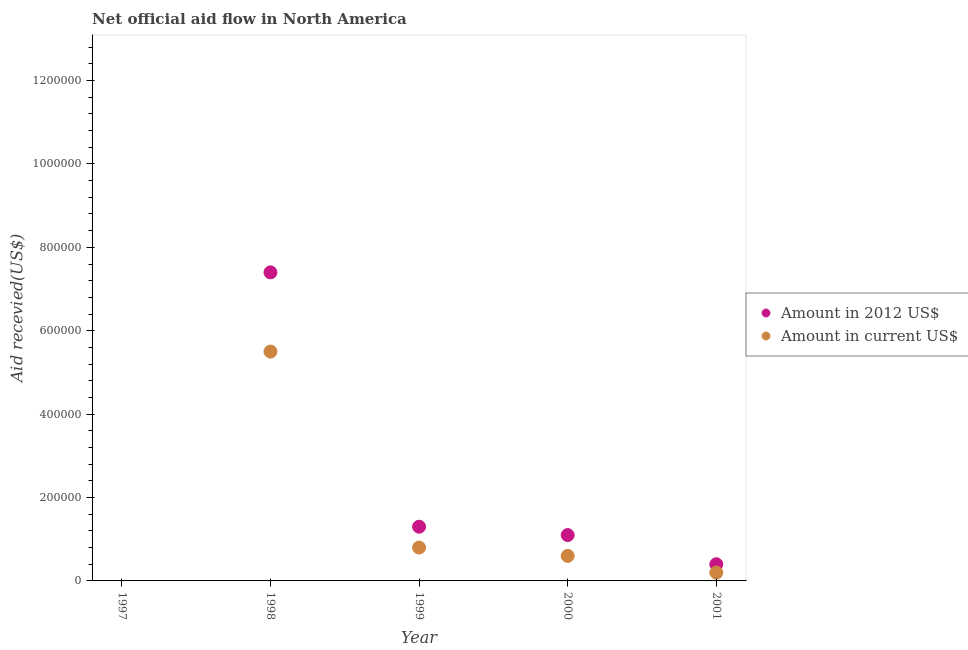How many different coloured dotlines are there?
Make the answer very short. 2. Is the number of dotlines equal to the number of legend labels?
Ensure brevity in your answer.  No. What is the amount of aid received(expressed in us$) in 1997?
Keep it short and to the point. 0. Across all years, what is the maximum amount of aid received(expressed in us$)?
Ensure brevity in your answer.  5.50e+05. In which year was the amount of aid received(expressed in 2012 us$) maximum?
Your response must be concise. 1998. What is the total amount of aid received(expressed in 2012 us$) in the graph?
Your response must be concise. 1.02e+06. What is the difference between the amount of aid received(expressed in us$) in 1998 and that in 2001?
Your answer should be very brief. 5.30e+05. What is the difference between the amount of aid received(expressed in 2012 us$) in 2001 and the amount of aid received(expressed in us$) in 2000?
Offer a very short reply. -2.00e+04. What is the average amount of aid received(expressed in us$) per year?
Make the answer very short. 1.42e+05. In the year 2001, what is the difference between the amount of aid received(expressed in us$) and amount of aid received(expressed in 2012 us$)?
Provide a short and direct response. -2.00e+04. In how many years, is the amount of aid received(expressed in 2012 us$) greater than 480000 US$?
Provide a short and direct response. 1. What is the ratio of the amount of aid received(expressed in us$) in 1998 to that in 1999?
Offer a terse response. 6.88. Is the amount of aid received(expressed in us$) in 2000 less than that in 2001?
Provide a succinct answer. No. Is the difference between the amount of aid received(expressed in us$) in 1999 and 2001 greater than the difference between the amount of aid received(expressed in 2012 us$) in 1999 and 2001?
Offer a very short reply. No. What is the difference between the highest and the second highest amount of aid received(expressed in us$)?
Make the answer very short. 4.70e+05. What is the difference between the highest and the lowest amount of aid received(expressed in 2012 us$)?
Your answer should be compact. 7.40e+05. Does the amount of aid received(expressed in 2012 us$) monotonically increase over the years?
Offer a terse response. No. Is the amount of aid received(expressed in us$) strictly greater than the amount of aid received(expressed in 2012 us$) over the years?
Your answer should be compact. No. How many years are there in the graph?
Offer a terse response. 5. Are the values on the major ticks of Y-axis written in scientific E-notation?
Provide a succinct answer. No. Does the graph contain any zero values?
Your answer should be compact. Yes. Does the graph contain grids?
Your answer should be compact. No. Where does the legend appear in the graph?
Ensure brevity in your answer.  Center right. How many legend labels are there?
Keep it short and to the point. 2. How are the legend labels stacked?
Ensure brevity in your answer.  Vertical. What is the title of the graph?
Your answer should be compact. Net official aid flow in North America. What is the label or title of the Y-axis?
Your answer should be very brief. Aid recevied(US$). What is the Aid recevied(US$) in Amount in 2012 US$ in 1997?
Provide a short and direct response. 0. What is the Aid recevied(US$) in Amount in current US$ in 1997?
Your answer should be very brief. 0. What is the Aid recevied(US$) of Amount in 2012 US$ in 1998?
Your answer should be compact. 7.40e+05. What is the Aid recevied(US$) in Amount in 2012 US$ in 1999?
Provide a short and direct response. 1.30e+05. What is the Aid recevied(US$) of Amount in current US$ in 1999?
Your answer should be compact. 8.00e+04. What is the Aid recevied(US$) of Amount in current US$ in 2000?
Provide a short and direct response. 6.00e+04. What is the Aid recevied(US$) of Amount in 2012 US$ in 2001?
Your answer should be compact. 4.00e+04. Across all years, what is the maximum Aid recevied(US$) of Amount in 2012 US$?
Give a very brief answer. 7.40e+05. Across all years, what is the maximum Aid recevied(US$) in Amount in current US$?
Make the answer very short. 5.50e+05. Across all years, what is the minimum Aid recevied(US$) of Amount in current US$?
Make the answer very short. 0. What is the total Aid recevied(US$) in Amount in 2012 US$ in the graph?
Provide a succinct answer. 1.02e+06. What is the total Aid recevied(US$) of Amount in current US$ in the graph?
Your response must be concise. 7.10e+05. What is the difference between the Aid recevied(US$) of Amount in 2012 US$ in 1998 and that in 1999?
Your answer should be compact. 6.10e+05. What is the difference between the Aid recevied(US$) in Amount in current US$ in 1998 and that in 1999?
Your answer should be very brief. 4.70e+05. What is the difference between the Aid recevied(US$) in Amount in 2012 US$ in 1998 and that in 2000?
Keep it short and to the point. 6.30e+05. What is the difference between the Aid recevied(US$) in Amount in current US$ in 1998 and that in 2001?
Give a very brief answer. 5.30e+05. What is the difference between the Aid recevied(US$) in Amount in 2012 US$ in 1999 and that in 2000?
Offer a very short reply. 2.00e+04. What is the difference between the Aid recevied(US$) in Amount in current US$ in 1999 and that in 2000?
Offer a very short reply. 2.00e+04. What is the difference between the Aid recevied(US$) in Amount in 2012 US$ in 1999 and that in 2001?
Offer a terse response. 9.00e+04. What is the difference between the Aid recevied(US$) of Amount in current US$ in 2000 and that in 2001?
Provide a short and direct response. 4.00e+04. What is the difference between the Aid recevied(US$) in Amount in 2012 US$ in 1998 and the Aid recevied(US$) in Amount in current US$ in 2000?
Your answer should be compact. 6.80e+05. What is the difference between the Aid recevied(US$) in Amount in 2012 US$ in 1998 and the Aid recevied(US$) in Amount in current US$ in 2001?
Ensure brevity in your answer.  7.20e+05. What is the difference between the Aid recevied(US$) of Amount in 2012 US$ in 1999 and the Aid recevied(US$) of Amount in current US$ in 2000?
Your answer should be very brief. 7.00e+04. What is the difference between the Aid recevied(US$) in Amount in 2012 US$ in 1999 and the Aid recevied(US$) in Amount in current US$ in 2001?
Make the answer very short. 1.10e+05. What is the average Aid recevied(US$) of Amount in 2012 US$ per year?
Offer a terse response. 2.04e+05. What is the average Aid recevied(US$) in Amount in current US$ per year?
Make the answer very short. 1.42e+05. In the year 1998, what is the difference between the Aid recevied(US$) in Amount in 2012 US$ and Aid recevied(US$) in Amount in current US$?
Offer a terse response. 1.90e+05. In the year 1999, what is the difference between the Aid recevied(US$) in Amount in 2012 US$ and Aid recevied(US$) in Amount in current US$?
Keep it short and to the point. 5.00e+04. In the year 2001, what is the difference between the Aid recevied(US$) in Amount in 2012 US$ and Aid recevied(US$) in Amount in current US$?
Make the answer very short. 2.00e+04. What is the ratio of the Aid recevied(US$) of Amount in 2012 US$ in 1998 to that in 1999?
Give a very brief answer. 5.69. What is the ratio of the Aid recevied(US$) in Amount in current US$ in 1998 to that in 1999?
Offer a terse response. 6.88. What is the ratio of the Aid recevied(US$) in Amount in 2012 US$ in 1998 to that in 2000?
Your answer should be compact. 6.73. What is the ratio of the Aid recevied(US$) in Amount in current US$ in 1998 to that in 2000?
Offer a terse response. 9.17. What is the ratio of the Aid recevied(US$) in Amount in 2012 US$ in 1998 to that in 2001?
Ensure brevity in your answer.  18.5. What is the ratio of the Aid recevied(US$) of Amount in current US$ in 1998 to that in 2001?
Offer a very short reply. 27.5. What is the ratio of the Aid recevied(US$) of Amount in 2012 US$ in 1999 to that in 2000?
Provide a short and direct response. 1.18. What is the ratio of the Aid recevied(US$) of Amount in current US$ in 1999 to that in 2000?
Offer a terse response. 1.33. What is the ratio of the Aid recevied(US$) of Amount in 2012 US$ in 1999 to that in 2001?
Your answer should be very brief. 3.25. What is the ratio of the Aid recevied(US$) of Amount in 2012 US$ in 2000 to that in 2001?
Provide a succinct answer. 2.75. What is the difference between the highest and the second highest Aid recevied(US$) in Amount in 2012 US$?
Your answer should be compact. 6.10e+05. What is the difference between the highest and the lowest Aid recevied(US$) in Amount in 2012 US$?
Offer a very short reply. 7.40e+05. 